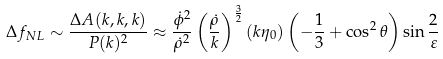<formula> <loc_0><loc_0><loc_500><loc_500>\Delta f _ { N L } \sim \frac { \Delta A ( { k } , { k } , { k } ) } { P ( { k } ) ^ { 2 } } \approx \frac { \dot { \phi } ^ { 2 } } { \dot { \rho } ^ { 2 } } \left ( \frac { \dot { \rho } } { k } \right ) ^ { \frac { 3 } { 2 } } ( k \eta _ { 0 } ) \left ( - \frac { 1 } { 3 } + \cos ^ { 2 } { \theta } \right ) \sin { \frac { 2 } { \varepsilon } }</formula> 